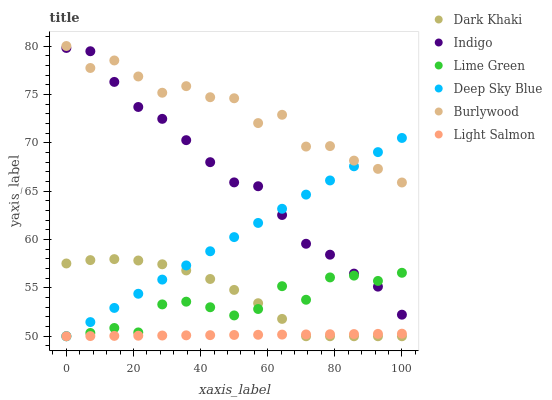Does Light Salmon have the minimum area under the curve?
Answer yes or no. Yes. Does Burlywood have the maximum area under the curve?
Answer yes or no. Yes. Does Indigo have the minimum area under the curve?
Answer yes or no. No. Does Indigo have the maximum area under the curve?
Answer yes or no. No. Is Deep Sky Blue the smoothest?
Answer yes or no. Yes. Is Burlywood the roughest?
Answer yes or no. Yes. Is Indigo the smoothest?
Answer yes or no. No. Is Indigo the roughest?
Answer yes or no. No. Does Light Salmon have the lowest value?
Answer yes or no. Yes. Does Indigo have the lowest value?
Answer yes or no. No. Does Burlywood have the highest value?
Answer yes or no. Yes. Does Indigo have the highest value?
Answer yes or no. No. Is Dark Khaki less than Burlywood?
Answer yes or no. Yes. Is Indigo greater than Dark Khaki?
Answer yes or no. Yes. Does Deep Sky Blue intersect Light Salmon?
Answer yes or no. Yes. Is Deep Sky Blue less than Light Salmon?
Answer yes or no. No. Is Deep Sky Blue greater than Light Salmon?
Answer yes or no. No. Does Dark Khaki intersect Burlywood?
Answer yes or no. No. 